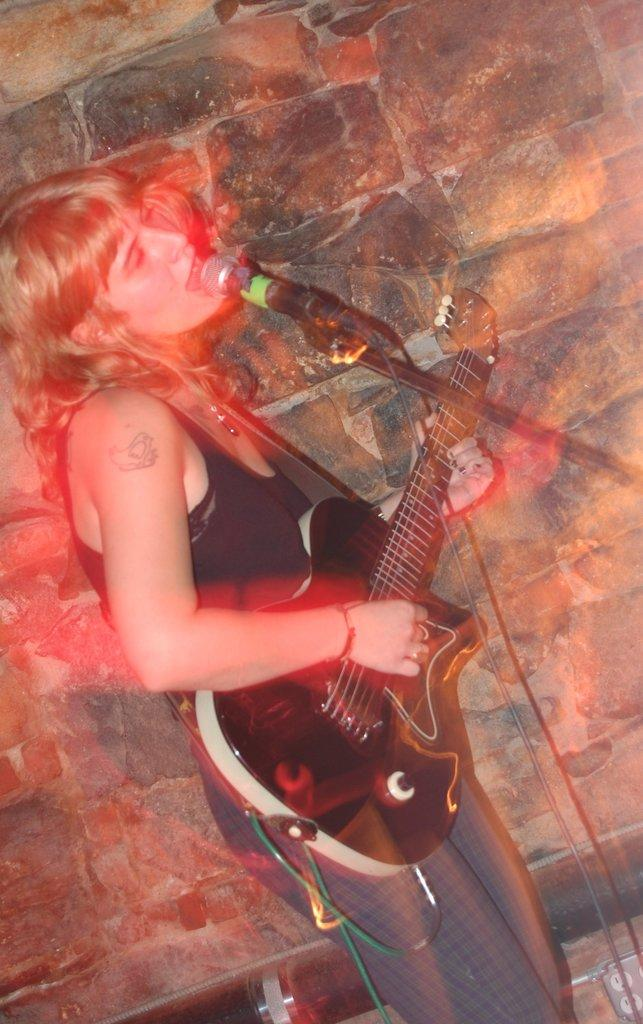Who is the main subject in the image? There is a woman in the image. What is the woman doing in the image? The woman is standing, playing a guitar, and singing. How many lizards can be seen crawling on the building in the image? There are no lizards or buildings present in the image; it features a woman playing a guitar and singing. 